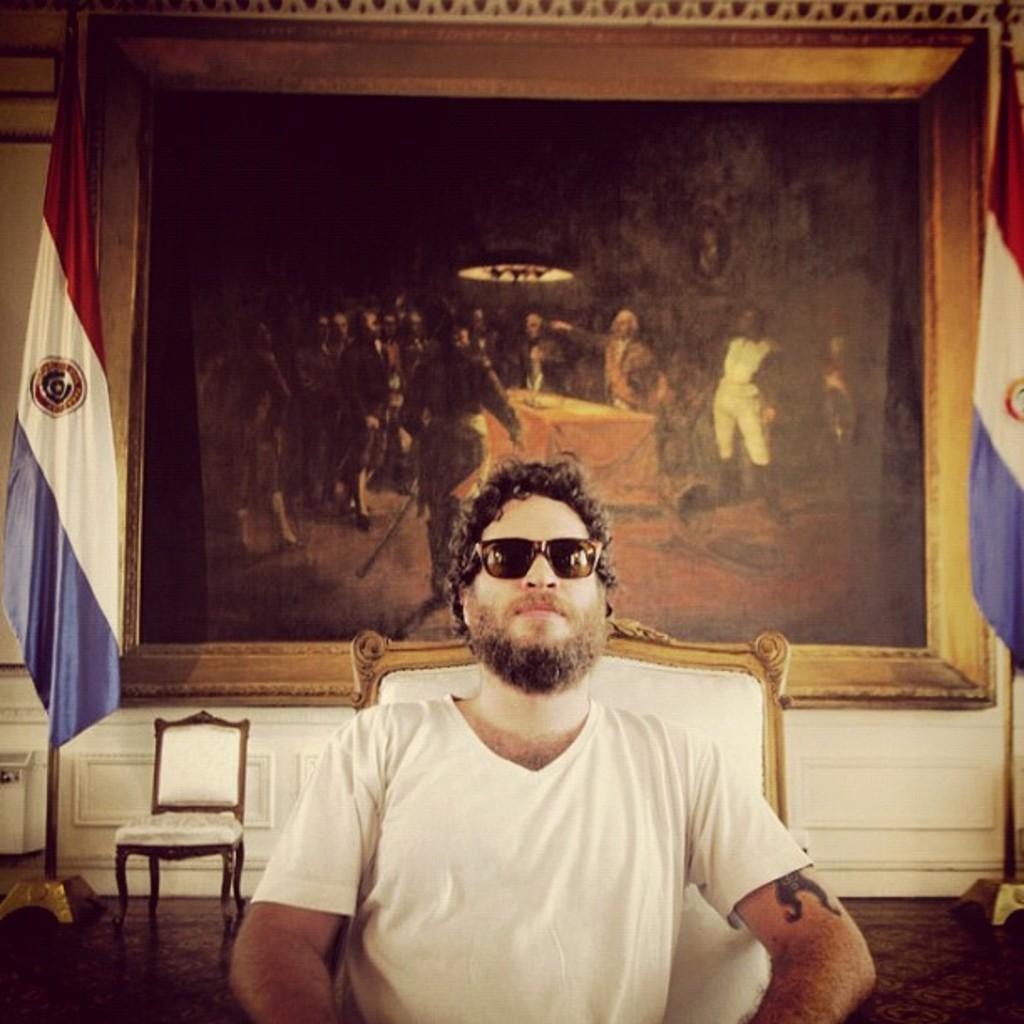What is the main subject of the image? There is a man in the image. What is the man wearing? The man is wearing a white t-shirt. What is the man doing in the image? The man is sitting on a chair. What can be seen in the background of the image? There are chairs, a photo frame, and flags in the background of the image. What type of hook can be seen on the man's skin in the image? There is no hook visible on the man's skin in the image. What type of plant is growing in the background of the image? There is no plant visible in the background of the image. 